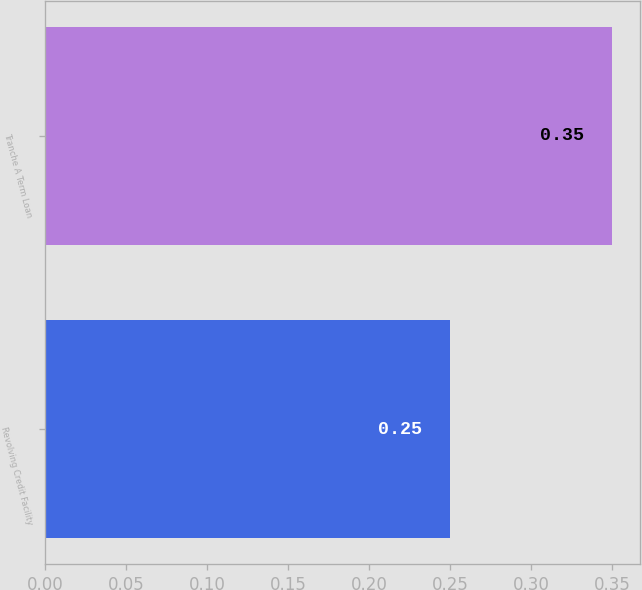<chart> <loc_0><loc_0><loc_500><loc_500><bar_chart><fcel>Revolving Credit Facility<fcel>Tranche A Term Loan<nl><fcel>0.25<fcel>0.35<nl></chart> 